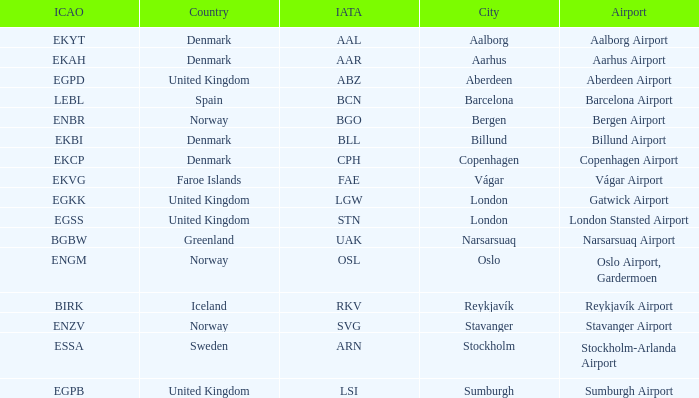What airport has an IATA of ARN? Stockholm-Arlanda Airport. 